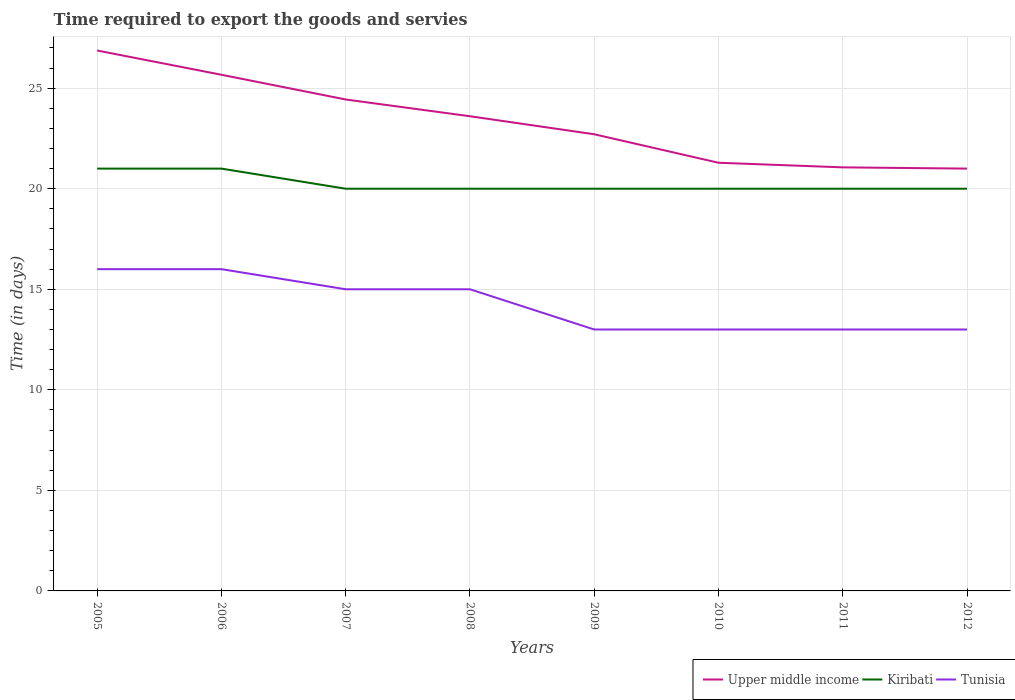How many different coloured lines are there?
Ensure brevity in your answer.  3. Is the number of lines equal to the number of legend labels?
Provide a short and direct response. Yes. Across all years, what is the maximum number of days required to export the goods and services in Tunisia?
Your answer should be very brief. 13. In which year was the number of days required to export the goods and services in Upper middle income maximum?
Your response must be concise. 2012. What is the total number of days required to export the goods and services in Upper middle income in the graph?
Give a very brief answer. 3.27. What is the difference between the highest and the second highest number of days required to export the goods and services in Tunisia?
Provide a succinct answer. 3. What is the difference between the highest and the lowest number of days required to export the goods and services in Tunisia?
Offer a very short reply. 4. Is the number of days required to export the goods and services in Kiribati strictly greater than the number of days required to export the goods and services in Tunisia over the years?
Make the answer very short. No. How many lines are there?
Keep it short and to the point. 3. Does the graph contain any zero values?
Give a very brief answer. No. Where does the legend appear in the graph?
Offer a terse response. Bottom right. How many legend labels are there?
Give a very brief answer. 3. How are the legend labels stacked?
Provide a short and direct response. Horizontal. What is the title of the graph?
Offer a terse response. Time required to export the goods and servies. Does "Thailand" appear as one of the legend labels in the graph?
Your response must be concise. No. What is the label or title of the Y-axis?
Your response must be concise. Time (in days). What is the Time (in days) of Upper middle income in 2005?
Offer a very short reply. 26.87. What is the Time (in days) of Tunisia in 2005?
Your answer should be compact. 16. What is the Time (in days) in Upper middle income in 2006?
Give a very brief answer. 25.67. What is the Time (in days) in Kiribati in 2006?
Ensure brevity in your answer.  21. What is the Time (in days) in Upper middle income in 2007?
Make the answer very short. 24.44. What is the Time (in days) of Kiribati in 2007?
Make the answer very short. 20. What is the Time (in days) of Tunisia in 2007?
Your response must be concise. 15. What is the Time (in days) of Upper middle income in 2008?
Offer a very short reply. 23.6. What is the Time (in days) in Kiribati in 2008?
Offer a terse response. 20. What is the Time (in days) of Upper middle income in 2009?
Provide a short and direct response. 22.71. What is the Time (in days) of Kiribati in 2009?
Make the answer very short. 20. What is the Time (in days) in Upper middle income in 2010?
Offer a terse response. 21.29. What is the Time (in days) of Kiribati in 2010?
Provide a succinct answer. 20. What is the Time (in days) of Tunisia in 2010?
Offer a very short reply. 13. What is the Time (in days) in Upper middle income in 2011?
Your answer should be compact. 21.06. What is the Time (in days) in Kiribati in 2011?
Offer a very short reply. 20. What is the Time (in days) of Tunisia in 2011?
Your answer should be compact. 13. What is the Time (in days) of Kiribati in 2012?
Make the answer very short. 20. Across all years, what is the maximum Time (in days) of Upper middle income?
Give a very brief answer. 26.87. Across all years, what is the maximum Time (in days) in Kiribati?
Provide a short and direct response. 21. Across all years, what is the minimum Time (in days) in Upper middle income?
Your answer should be very brief. 21. Across all years, what is the minimum Time (in days) in Kiribati?
Your answer should be compact. 20. What is the total Time (in days) in Upper middle income in the graph?
Offer a terse response. 186.64. What is the total Time (in days) of Kiribati in the graph?
Provide a succinct answer. 162. What is the total Time (in days) of Tunisia in the graph?
Make the answer very short. 114. What is the difference between the Time (in days) in Upper middle income in 2005 and that in 2006?
Your response must be concise. 1.21. What is the difference between the Time (in days) of Upper middle income in 2005 and that in 2007?
Your response must be concise. 2.43. What is the difference between the Time (in days) of Kiribati in 2005 and that in 2007?
Offer a terse response. 1. What is the difference between the Time (in days) in Upper middle income in 2005 and that in 2008?
Your response must be concise. 3.27. What is the difference between the Time (in days) of Tunisia in 2005 and that in 2008?
Provide a short and direct response. 1. What is the difference between the Time (in days) in Upper middle income in 2005 and that in 2009?
Make the answer very short. 4.16. What is the difference between the Time (in days) of Upper middle income in 2005 and that in 2010?
Your response must be concise. 5.58. What is the difference between the Time (in days) in Kiribati in 2005 and that in 2010?
Offer a very short reply. 1. What is the difference between the Time (in days) of Upper middle income in 2005 and that in 2011?
Give a very brief answer. 5.81. What is the difference between the Time (in days) in Kiribati in 2005 and that in 2011?
Your answer should be compact. 1. What is the difference between the Time (in days) in Upper middle income in 2005 and that in 2012?
Your answer should be very brief. 5.87. What is the difference between the Time (in days) of Kiribati in 2005 and that in 2012?
Your response must be concise. 1. What is the difference between the Time (in days) in Upper middle income in 2006 and that in 2007?
Your response must be concise. 1.23. What is the difference between the Time (in days) in Tunisia in 2006 and that in 2007?
Give a very brief answer. 1. What is the difference between the Time (in days) of Upper middle income in 2006 and that in 2008?
Your answer should be compact. 2.06. What is the difference between the Time (in days) in Kiribati in 2006 and that in 2008?
Provide a succinct answer. 1. What is the difference between the Time (in days) in Upper middle income in 2006 and that in 2009?
Offer a terse response. 2.96. What is the difference between the Time (in days) in Upper middle income in 2006 and that in 2010?
Your answer should be compact. 4.38. What is the difference between the Time (in days) in Upper middle income in 2006 and that in 2011?
Your response must be concise. 4.6. What is the difference between the Time (in days) in Upper middle income in 2006 and that in 2012?
Give a very brief answer. 4.67. What is the difference between the Time (in days) of Kiribati in 2006 and that in 2012?
Keep it short and to the point. 1. What is the difference between the Time (in days) of Kiribati in 2007 and that in 2008?
Make the answer very short. 0. What is the difference between the Time (in days) of Tunisia in 2007 and that in 2008?
Your answer should be very brief. 0. What is the difference between the Time (in days) in Upper middle income in 2007 and that in 2009?
Your response must be concise. 1.73. What is the difference between the Time (in days) in Tunisia in 2007 and that in 2009?
Offer a very short reply. 2. What is the difference between the Time (in days) of Upper middle income in 2007 and that in 2010?
Your response must be concise. 3.15. What is the difference between the Time (in days) in Kiribati in 2007 and that in 2010?
Your answer should be very brief. 0. What is the difference between the Time (in days) of Tunisia in 2007 and that in 2010?
Ensure brevity in your answer.  2. What is the difference between the Time (in days) of Upper middle income in 2007 and that in 2011?
Your answer should be very brief. 3.38. What is the difference between the Time (in days) in Upper middle income in 2007 and that in 2012?
Ensure brevity in your answer.  3.44. What is the difference between the Time (in days) of Upper middle income in 2008 and that in 2009?
Provide a succinct answer. 0.9. What is the difference between the Time (in days) of Kiribati in 2008 and that in 2009?
Ensure brevity in your answer.  0. What is the difference between the Time (in days) in Tunisia in 2008 and that in 2009?
Your response must be concise. 2. What is the difference between the Time (in days) in Upper middle income in 2008 and that in 2010?
Your answer should be very brief. 2.31. What is the difference between the Time (in days) of Upper middle income in 2008 and that in 2011?
Provide a succinct answer. 2.54. What is the difference between the Time (in days) of Upper middle income in 2008 and that in 2012?
Make the answer very short. 2.6. What is the difference between the Time (in days) of Tunisia in 2008 and that in 2012?
Offer a very short reply. 2. What is the difference between the Time (in days) in Upper middle income in 2009 and that in 2010?
Provide a succinct answer. 1.42. What is the difference between the Time (in days) in Kiribati in 2009 and that in 2010?
Give a very brief answer. 0. What is the difference between the Time (in days) in Upper middle income in 2009 and that in 2011?
Your answer should be very brief. 1.65. What is the difference between the Time (in days) of Tunisia in 2009 and that in 2011?
Give a very brief answer. 0. What is the difference between the Time (in days) in Upper middle income in 2009 and that in 2012?
Make the answer very short. 1.71. What is the difference between the Time (in days) of Kiribati in 2009 and that in 2012?
Your answer should be compact. 0. What is the difference between the Time (in days) in Tunisia in 2009 and that in 2012?
Make the answer very short. 0. What is the difference between the Time (in days) in Upper middle income in 2010 and that in 2011?
Your response must be concise. 0.23. What is the difference between the Time (in days) in Kiribati in 2010 and that in 2011?
Your answer should be very brief. 0. What is the difference between the Time (in days) in Upper middle income in 2010 and that in 2012?
Ensure brevity in your answer.  0.29. What is the difference between the Time (in days) of Tunisia in 2010 and that in 2012?
Your response must be concise. 0. What is the difference between the Time (in days) in Upper middle income in 2011 and that in 2012?
Provide a short and direct response. 0.06. What is the difference between the Time (in days) in Kiribati in 2011 and that in 2012?
Offer a terse response. 0. What is the difference between the Time (in days) of Upper middle income in 2005 and the Time (in days) of Kiribati in 2006?
Your response must be concise. 5.87. What is the difference between the Time (in days) of Upper middle income in 2005 and the Time (in days) of Tunisia in 2006?
Give a very brief answer. 10.87. What is the difference between the Time (in days) of Kiribati in 2005 and the Time (in days) of Tunisia in 2006?
Provide a succinct answer. 5. What is the difference between the Time (in days) in Upper middle income in 2005 and the Time (in days) in Kiribati in 2007?
Your response must be concise. 6.87. What is the difference between the Time (in days) of Upper middle income in 2005 and the Time (in days) of Tunisia in 2007?
Your answer should be very brief. 11.87. What is the difference between the Time (in days) of Kiribati in 2005 and the Time (in days) of Tunisia in 2007?
Make the answer very short. 6. What is the difference between the Time (in days) of Upper middle income in 2005 and the Time (in days) of Kiribati in 2008?
Provide a succinct answer. 6.87. What is the difference between the Time (in days) in Upper middle income in 2005 and the Time (in days) in Tunisia in 2008?
Your answer should be very brief. 11.87. What is the difference between the Time (in days) in Kiribati in 2005 and the Time (in days) in Tunisia in 2008?
Your answer should be compact. 6. What is the difference between the Time (in days) in Upper middle income in 2005 and the Time (in days) in Kiribati in 2009?
Your answer should be compact. 6.87. What is the difference between the Time (in days) in Upper middle income in 2005 and the Time (in days) in Tunisia in 2009?
Provide a short and direct response. 13.87. What is the difference between the Time (in days) in Upper middle income in 2005 and the Time (in days) in Kiribati in 2010?
Your response must be concise. 6.87. What is the difference between the Time (in days) of Upper middle income in 2005 and the Time (in days) of Tunisia in 2010?
Offer a terse response. 13.87. What is the difference between the Time (in days) in Kiribati in 2005 and the Time (in days) in Tunisia in 2010?
Your response must be concise. 8. What is the difference between the Time (in days) in Upper middle income in 2005 and the Time (in days) in Kiribati in 2011?
Your answer should be compact. 6.87. What is the difference between the Time (in days) in Upper middle income in 2005 and the Time (in days) in Tunisia in 2011?
Your answer should be very brief. 13.87. What is the difference between the Time (in days) in Upper middle income in 2005 and the Time (in days) in Kiribati in 2012?
Offer a terse response. 6.87. What is the difference between the Time (in days) of Upper middle income in 2005 and the Time (in days) of Tunisia in 2012?
Your response must be concise. 13.87. What is the difference between the Time (in days) in Kiribati in 2005 and the Time (in days) in Tunisia in 2012?
Give a very brief answer. 8. What is the difference between the Time (in days) of Upper middle income in 2006 and the Time (in days) of Kiribati in 2007?
Keep it short and to the point. 5.67. What is the difference between the Time (in days) in Upper middle income in 2006 and the Time (in days) in Tunisia in 2007?
Make the answer very short. 10.67. What is the difference between the Time (in days) of Upper middle income in 2006 and the Time (in days) of Kiribati in 2008?
Provide a succinct answer. 5.67. What is the difference between the Time (in days) in Upper middle income in 2006 and the Time (in days) in Tunisia in 2008?
Provide a short and direct response. 10.67. What is the difference between the Time (in days) in Upper middle income in 2006 and the Time (in days) in Kiribati in 2009?
Offer a terse response. 5.67. What is the difference between the Time (in days) in Upper middle income in 2006 and the Time (in days) in Tunisia in 2009?
Provide a succinct answer. 12.67. What is the difference between the Time (in days) in Kiribati in 2006 and the Time (in days) in Tunisia in 2009?
Make the answer very short. 8. What is the difference between the Time (in days) in Upper middle income in 2006 and the Time (in days) in Kiribati in 2010?
Your response must be concise. 5.67. What is the difference between the Time (in days) of Upper middle income in 2006 and the Time (in days) of Tunisia in 2010?
Offer a terse response. 12.67. What is the difference between the Time (in days) in Kiribati in 2006 and the Time (in days) in Tunisia in 2010?
Provide a short and direct response. 8. What is the difference between the Time (in days) in Upper middle income in 2006 and the Time (in days) in Kiribati in 2011?
Keep it short and to the point. 5.67. What is the difference between the Time (in days) in Upper middle income in 2006 and the Time (in days) in Tunisia in 2011?
Your response must be concise. 12.67. What is the difference between the Time (in days) in Kiribati in 2006 and the Time (in days) in Tunisia in 2011?
Provide a short and direct response. 8. What is the difference between the Time (in days) of Upper middle income in 2006 and the Time (in days) of Kiribati in 2012?
Provide a short and direct response. 5.67. What is the difference between the Time (in days) of Upper middle income in 2006 and the Time (in days) of Tunisia in 2012?
Make the answer very short. 12.67. What is the difference between the Time (in days) of Kiribati in 2006 and the Time (in days) of Tunisia in 2012?
Your response must be concise. 8. What is the difference between the Time (in days) in Upper middle income in 2007 and the Time (in days) in Kiribati in 2008?
Offer a terse response. 4.44. What is the difference between the Time (in days) in Upper middle income in 2007 and the Time (in days) in Tunisia in 2008?
Your answer should be compact. 9.44. What is the difference between the Time (in days) in Kiribati in 2007 and the Time (in days) in Tunisia in 2008?
Give a very brief answer. 5. What is the difference between the Time (in days) in Upper middle income in 2007 and the Time (in days) in Kiribati in 2009?
Your response must be concise. 4.44. What is the difference between the Time (in days) in Upper middle income in 2007 and the Time (in days) in Tunisia in 2009?
Ensure brevity in your answer.  11.44. What is the difference between the Time (in days) of Upper middle income in 2007 and the Time (in days) of Kiribati in 2010?
Offer a terse response. 4.44. What is the difference between the Time (in days) of Upper middle income in 2007 and the Time (in days) of Tunisia in 2010?
Provide a succinct answer. 11.44. What is the difference between the Time (in days) in Kiribati in 2007 and the Time (in days) in Tunisia in 2010?
Offer a very short reply. 7. What is the difference between the Time (in days) in Upper middle income in 2007 and the Time (in days) in Kiribati in 2011?
Provide a short and direct response. 4.44. What is the difference between the Time (in days) of Upper middle income in 2007 and the Time (in days) of Tunisia in 2011?
Provide a succinct answer. 11.44. What is the difference between the Time (in days) in Upper middle income in 2007 and the Time (in days) in Kiribati in 2012?
Keep it short and to the point. 4.44. What is the difference between the Time (in days) in Upper middle income in 2007 and the Time (in days) in Tunisia in 2012?
Your answer should be very brief. 11.44. What is the difference between the Time (in days) in Upper middle income in 2008 and the Time (in days) in Kiribati in 2009?
Keep it short and to the point. 3.6. What is the difference between the Time (in days) of Upper middle income in 2008 and the Time (in days) of Tunisia in 2009?
Provide a short and direct response. 10.6. What is the difference between the Time (in days) of Kiribati in 2008 and the Time (in days) of Tunisia in 2009?
Give a very brief answer. 7. What is the difference between the Time (in days) in Upper middle income in 2008 and the Time (in days) in Kiribati in 2010?
Your answer should be compact. 3.6. What is the difference between the Time (in days) in Upper middle income in 2008 and the Time (in days) in Tunisia in 2010?
Provide a succinct answer. 10.6. What is the difference between the Time (in days) of Upper middle income in 2008 and the Time (in days) of Kiribati in 2011?
Offer a terse response. 3.6. What is the difference between the Time (in days) in Upper middle income in 2008 and the Time (in days) in Tunisia in 2011?
Ensure brevity in your answer.  10.6. What is the difference between the Time (in days) in Upper middle income in 2008 and the Time (in days) in Kiribati in 2012?
Your answer should be compact. 3.6. What is the difference between the Time (in days) in Upper middle income in 2008 and the Time (in days) in Tunisia in 2012?
Provide a short and direct response. 10.6. What is the difference between the Time (in days) of Upper middle income in 2009 and the Time (in days) of Kiribati in 2010?
Your answer should be compact. 2.71. What is the difference between the Time (in days) in Upper middle income in 2009 and the Time (in days) in Tunisia in 2010?
Keep it short and to the point. 9.71. What is the difference between the Time (in days) in Upper middle income in 2009 and the Time (in days) in Kiribati in 2011?
Offer a very short reply. 2.71. What is the difference between the Time (in days) in Upper middle income in 2009 and the Time (in days) in Tunisia in 2011?
Keep it short and to the point. 9.71. What is the difference between the Time (in days) of Upper middle income in 2009 and the Time (in days) of Kiribati in 2012?
Keep it short and to the point. 2.71. What is the difference between the Time (in days) in Upper middle income in 2009 and the Time (in days) in Tunisia in 2012?
Give a very brief answer. 9.71. What is the difference between the Time (in days) of Upper middle income in 2010 and the Time (in days) of Kiribati in 2011?
Offer a very short reply. 1.29. What is the difference between the Time (in days) of Upper middle income in 2010 and the Time (in days) of Tunisia in 2011?
Give a very brief answer. 8.29. What is the difference between the Time (in days) in Upper middle income in 2010 and the Time (in days) in Kiribati in 2012?
Offer a terse response. 1.29. What is the difference between the Time (in days) in Upper middle income in 2010 and the Time (in days) in Tunisia in 2012?
Keep it short and to the point. 8.29. What is the difference between the Time (in days) of Upper middle income in 2011 and the Time (in days) of Tunisia in 2012?
Provide a succinct answer. 8.06. What is the average Time (in days) of Upper middle income per year?
Your response must be concise. 23.33. What is the average Time (in days) of Kiribati per year?
Offer a terse response. 20.25. What is the average Time (in days) in Tunisia per year?
Ensure brevity in your answer.  14.25. In the year 2005, what is the difference between the Time (in days) of Upper middle income and Time (in days) of Kiribati?
Keep it short and to the point. 5.87. In the year 2005, what is the difference between the Time (in days) in Upper middle income and Time (in days) in Tunisia?
Your response must be concise. 10.87. In the year 2005, what is the difference between the Time (in days) of Kiribati and Time (in days) of Tunisia?
Keep it short and to the point. 5. In the year 2006, what is the difference between the Time (in days) of Upper middle income and Time (in days) of Kiribati?
Your answer should be very brief. 4.67. In the year 2006, what is the difference between the Time (in days) in Upper middle income and Time (in days) in Tunisia?
Give a very brief answer. 9.67. In the year 2007, what is the difference between the Time (in days) of Upper middle income and Time (in days) of Kiribati?
Your response must be concise. 4.44. In the year 2007, what is the difference between the Time (in days) of Upper middle income and Time (in days) of Tunisia?
Provide a short and direct response. 9.44. In the year 2007, what is the difference between the Time (in days) of Kiribati and Time (in days) of Tunisia?
Your answer should be very brief. 5. In the year 2008, what is the difference between the Time (in days) in Upper middle income and Time (in days) in Kiribati?
Provide a short and direct response. 3.6. In the year 2008, what is the difference between the Time (in days) in Upper middle income and Time (in days) in Tunisia?
Keep it short and to the point. 8.6. In the year 2009, what is the difference between the Time (in days) of Upper middle income and Time (in days) of Kiribati?
Your response must be concise. 2.71. In the year 2009, what is the difference between the Time (in days) in Upper middle income and Time (in days) in Tunisia?
Give a very brief answer. 9.71. In the year 2009, what is the difference between the Time (in days) of Kiribati and Time (in days) of Tunisia?
Your answer should be compact. 7. In the year 2010, what is the difference between the Time (in days) in Upper middle income and Time (in days) in Kiribati?
Offer a very short reply. 1.29. In the year 2010, what is the difference between the Time (in days) in Upper middle income and Time (in days) in Tunisia?
Offer a very short reply. 8.29. In the year 2010, what is the difference between the Time (in days) in Kiribati and Time (in days) in Tunisia?
Offer a very short reply. 7. In the year 2011, what is the difference between the Time (in days) in Upper middle income and Time (in days) in Tunisia?
Your answer should be compact. 8.06. In the year 2011, what is the difference between the Time (in days) of Kiribati and Time (in days) of Tunisia?
Keep it short and to the point. 7. In the year 2012, what is the difference between the Time (in days) of Upper middle income and Time (in days) of Kiribati?
Offer a terse response. 1. In the year 2012, what is the difference between the Time (in days) in Upper middle income and Time (in days) in Tunisia?
Make the answer very short. 8. What is the ratio of the Time (in days) of Upper middle income in 2005 to that in 2006?
Keep it short and to the point. 1.05. What is the ratio of the Time (in days) in Upper middle income in 2005 to that in 2007?
Give a very brief answer. 1.1. What is the ratio of the Time (in days) in Kiribati in 2005 to that in 2007?
Your response must be concise. 1.05. What is the ratio of the Time (in days) in Tunisia in 2005 to that in 2007?
Make the answer very short. 1.07. What is the ratio of the Time (in days) of Upper middle income in 2005 to that in 2008?
Keep it short and to the point. 1.14. What is the ratio of the Time (in days) in Tunisia in 2005 to that in 2008?
Keep it short and to the point. 1.07. What is the ratio of the Time (in days) in Upper middle income in 2005 to that in 2009?
Provide a short and direct response. 1.18. What is the ratio of the Time (in days) in Tunisia in 2005 to that in 2009?
Keep it short and to the point. 1.23. What is the ratio of the Time (in days) of Upper middle income in 2005 to that in 2010?
Give a very brief answer. 1.26. What is the ratio of the Time (in days) of Kiribati in 2005 to that in 2010?
Your response must be concise. 1.05. What is the ratio of the Time (in days) of Tunisia in 2005 to that in 2010?
Your answer should be compact. 1.23. What is the ratio of the Time (in days) of Upper middle income in 2005 to that in 2011?
Provide a succinct answer. 1.28. What is the ratio of the Time (in days) of Kiribati in 2005 to that in 2011?
Your answer should be compact. 1.05. What is the ratio of the Time (in days) of Tunisia in 2005 to that in 2011?
Make the answer very short. 1.23. What is the ratio of the Time (in days) in Upper middle income in 2005 to that in 2012?
Your response must be concise. 1.28. What is the ratio of the Time (in days) of Tunisia in 2005 to that in 2012?
Give a very brief answer. 1.23. What is the ratio of the Time (in days) in Upper middle income in 2006 to that in 2007?
Offer a very short reply. 1.05. What is the ratio of the Time (in days) of Kiribati in 2006 to that in 2007?
Give a very brief answer. 1.05. What is the ratio of the Time (in days) in Tunisia in 2006 to that in 2007?
Ensure brevity in your answer.  1.07. What is the ratio of the Time (in days) in Upper middle income in 2006 to that in 2008?
Provide a short and direct response. 1.09. What is the ratio of the Time (in days) in Kiribati in 2006 to that in 2008?
Ensure brevity in your answer.  1.05. What is the ratio of the Time (in days) in Tunisia in 2006 to that in 2008?
Give a very brief answer. 1.07. What is the ratio of the Time (in days) in Upper middle income in 2006 to that in 2009?
Your answer should be compact. 1.13. What is the ratio of the Time (in days) of Kiribati in 2006 to that in 2009?
Give a very brief answer. 1.05. What is the ratio of the Time (in days) of Tunisia in 2006 to that in 2009?
Offer a terse response. 1.23. What is the ratio of the Time (in days) in Upper middle income in 2006 to that in 2010?
Offer a very short reply. 1.21. What is the ratio of the Time (in days) in Kiribati in 2006 to that in 2010?
Keep it short and to the point. 1.05. What is the ratio of the Time (in days) in Tunisia in 2006 to that in 2010?
Your response must be concise. 1.23. What is the ratio of the Time (in days) in Upper middle income in 2006 to that in 2011?
Offer a very short reply. 1.22. What is the ratio of the Time (in days) in Kiribati in 2006 to that in 2011?
Make the answer very short. 1.05. What is the ratio of the Time (in days) in Tunisia in 2006 to that in 2011?
Offer a very short reply. 1.23. What is the ratio of the Time (in days) of Upper middle income in 2006 to that in 2012?
Provide a short and direct response. 1.22. What is the ratio of the Time (in days) in Kiribati in 2006 to that in 2012?
Give a very brief answer. 1.05. What is the ratio of the Time (in days) in Tunisia in 2006 to that in 2012?
Your answer should be very brief. 1.23. What is the ratio of the Time (in days) of Upper middle income in 2007 to that in 2008?
Give a very brief answer. 1.04. What is the ratio of the Time (in days) in Kiribati in 2007 to that in 2008?
Make the answer very short. 1. What is the ratio of the Time (in days) of Upper middle income in 2007 to that in 2009?
Provide a succinct answer. 1.08. What is the ratio of the Time (in days) of Tunisia in 2007 to that in 2009?
Offer a very short reply. 1.15. What is the ratio of the Time (in days) of Upper middle income in 2007 to that in 2010?
Give a very brief answer. 1.15. What is the ratio of the Time (in days) of Tunisia in 2007 to that in 2010?
Keep it short and to the point. 1.15. What is the ratio of the Time (in days) in Upper middle income in 2007 to that in 2011?
Offer a terse response. 1.16. What is the ratio of the Time (in days) in Kiribati in 2007 to that in 2011?
Make the answer very short. 1. What is the ratio of the Time (in days) in Tunisia in 2007 to that in 2011?
Ensure brevity in your answer.  1.15. What is the ratio of the Time (in days) of Upper middle income in 2007 to that in 2012?
Provide a short and direct response. 1.16. What is the ratio of the Time (in days) in Tunisia in 2007 to that in 2012?
Ensure brevity in your answer.  1.15. What is the ratio of the Time (in days) of Upper middle income in 2008 to that in 2009?
Offer a terse response. 1.04. What is the ratio of the Time (in days) of Tunisia in 2008 to that in 2009?
Make the answer very short. 1.15. What is the ratio of the Time (in days) in Upper middle income in 2008 to that in 2010?
Make the answer very short. 1.11. What is the ratio of the Time (in days) of Kiribati in 2008 to that in 2010?
Offer a very short reply. 1. What is the ratio of the Time (in days) of Tunisia in 2008 to that in 2010?
Make the answer very short. 1.15. What is the ratio of the Time (in days) in Upper middle income in 2008 to that in 2011?
Give a very brief answer. 1.12. What is the ratio of the Time (in days) of Tunisia in 2008 to that in 2011?
Offer a very short reply. 1.15. What is the ratio of the Time (in days) of Upper middle income in 2008 to that in 2012?
Make the answer very short. 1.12. What is the ratio of the Time (in days) of Tunisia in 2008 to that in 2012?
Offer a terse response. 1.15. What is the ratio of the Time (in days) in Upper middle income in 2009 to that in 2010?
Your answer should be very brief. 1.07. What is the ratio of the Time (in days) in Tunisia in 2009 to that in 2010?
Provide a short and direct response. 1. What is the ratio of the Time (in days) in Upper middle income in 2009 to that in 2011?
Give a very brief answer. 1.08. What is the ratio of the Time (in days) in Kiribati in 2009 to that in 2011?
Ensure brevity in your answer.  1. What is the ratio of the Time (in days) of Upper middle income in 2009 to that in 2012?
Your response must be concise. 1.08. What is the ratio of the Time (in days) of Tunisia in 2009 to that in 2012?
Ensure brevity in your answer.  1. What is the ratio of the Time (in days) of Upper middle income in 2010 to that in 2011?
Provide a short and direct response. 1.01. What is the ratio of the Time (in days) of Tunisia in 2010 to that in 2011?
Make the answer very short. 1. What is the ratio of the Time (in days) in Upper middle income in 2010 to that in 2012?
Your response must be concise. 1.01. What is the ratio of the Time (in days) in Kiribati in 2010 to that in 2012?
Offer a very short reply. 1. What is the difference between the highest and the second highest Time (in days) in Upper middle income?
Your response must be concise. 1.21. What is the difference between the highest and the lowest Time (in days) in Upper middle income?
Give a very brief answer. 5.87. What is the difference between the highest and the lowest Time (in days) of Kiribati?
Offer a terse response. 1. What is the difference between the highest and the lowest Time (in days) in Tunisia?
Offer a terse response. 3. 